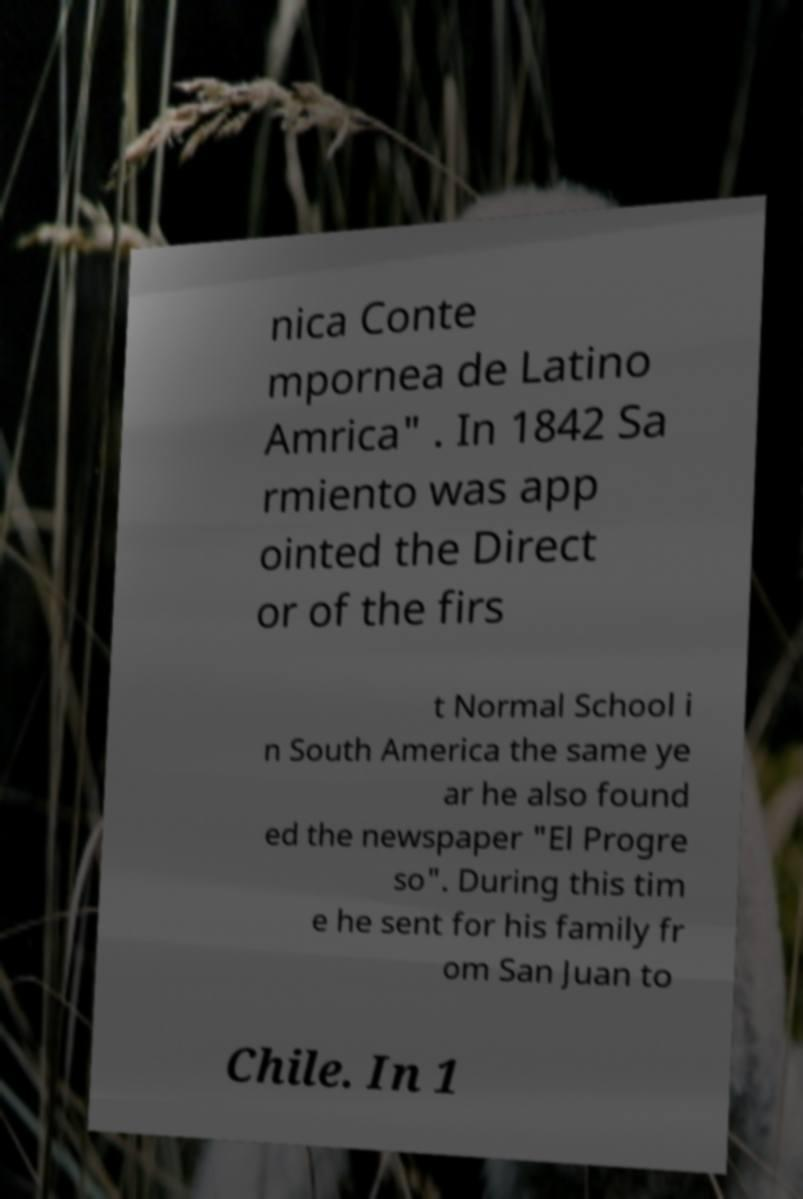There's text embedded in this image that I need extracted. Can you transcribe it verbatim? nica Conte mpornea de Latino Amrica" . In 1842 Sa rmiento was app ointed the Direct or of the firs t Normal School i n South America the same ye ar he also found ed the newspaper "El Progre so". During this tim e he sent for his family fr om San Juan to Chile. In 1 